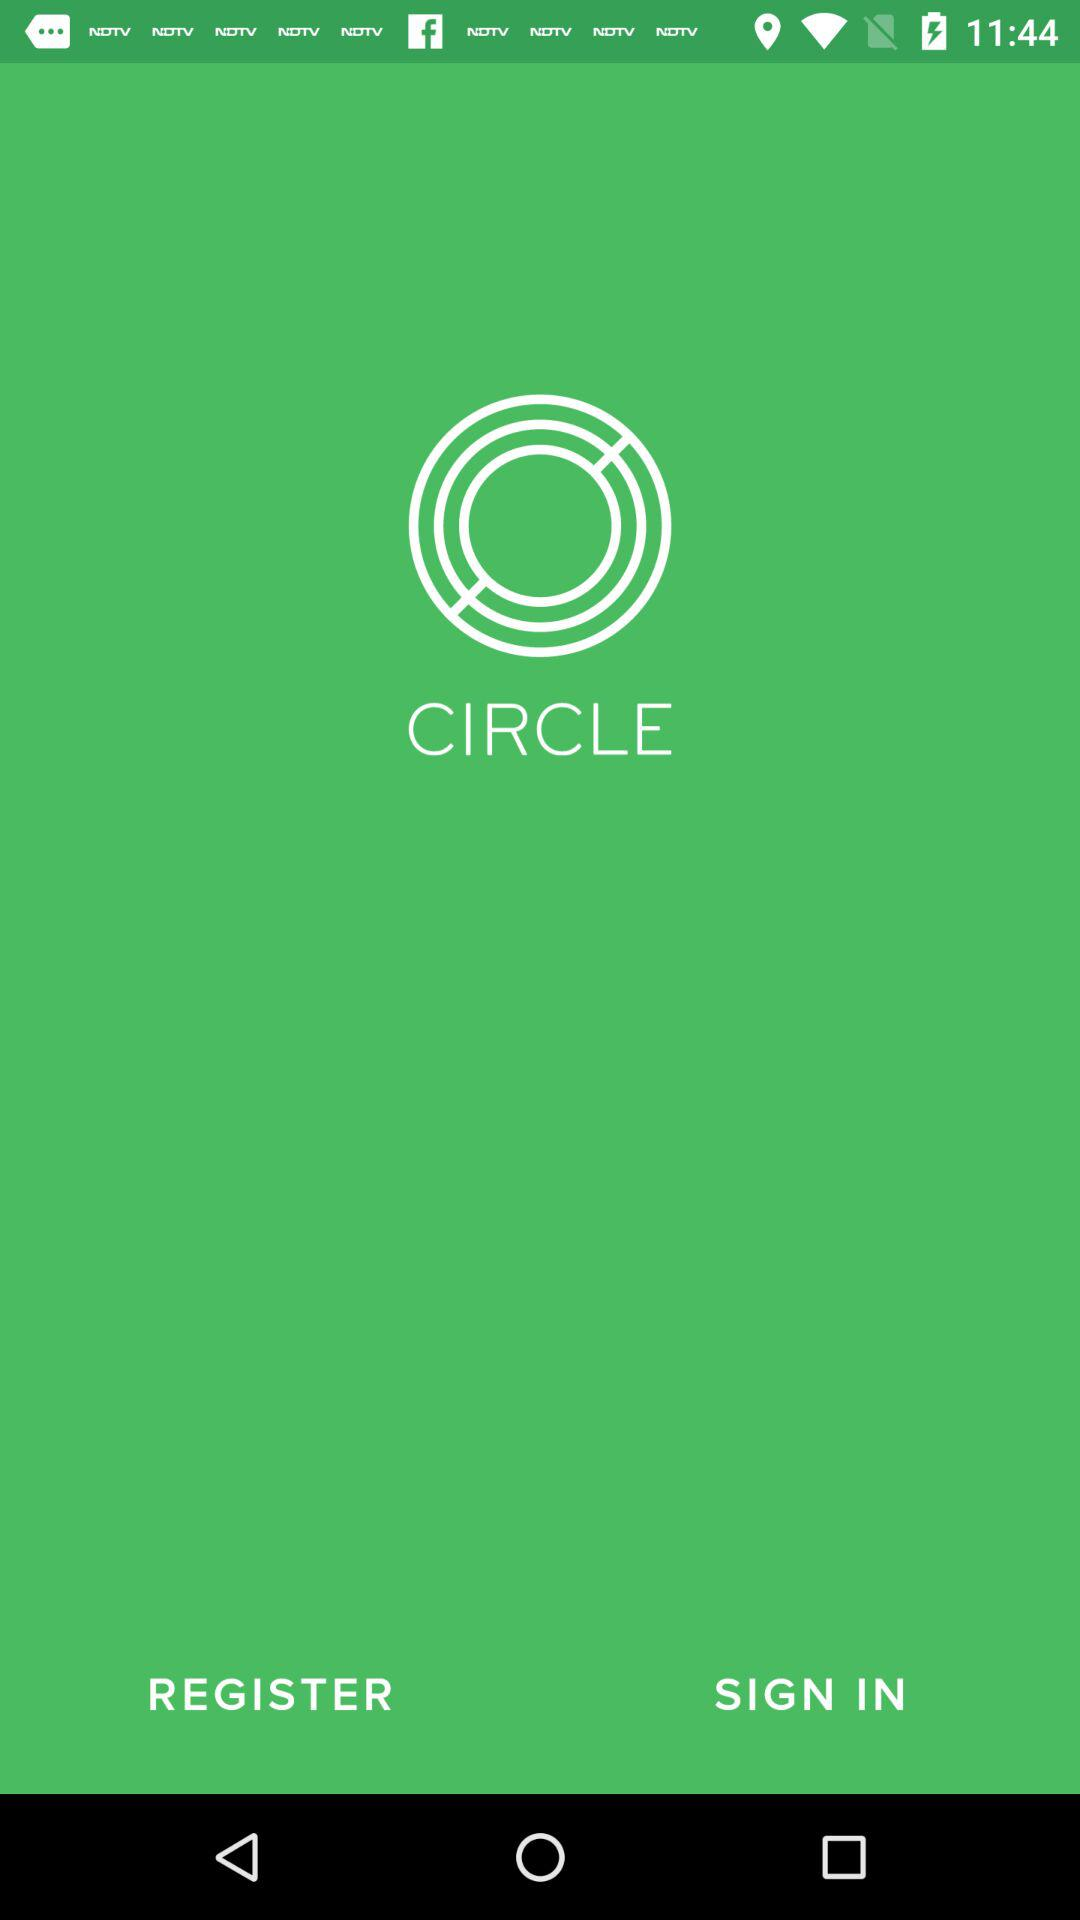What's the application name? The name of the application is "CIRCLE". 